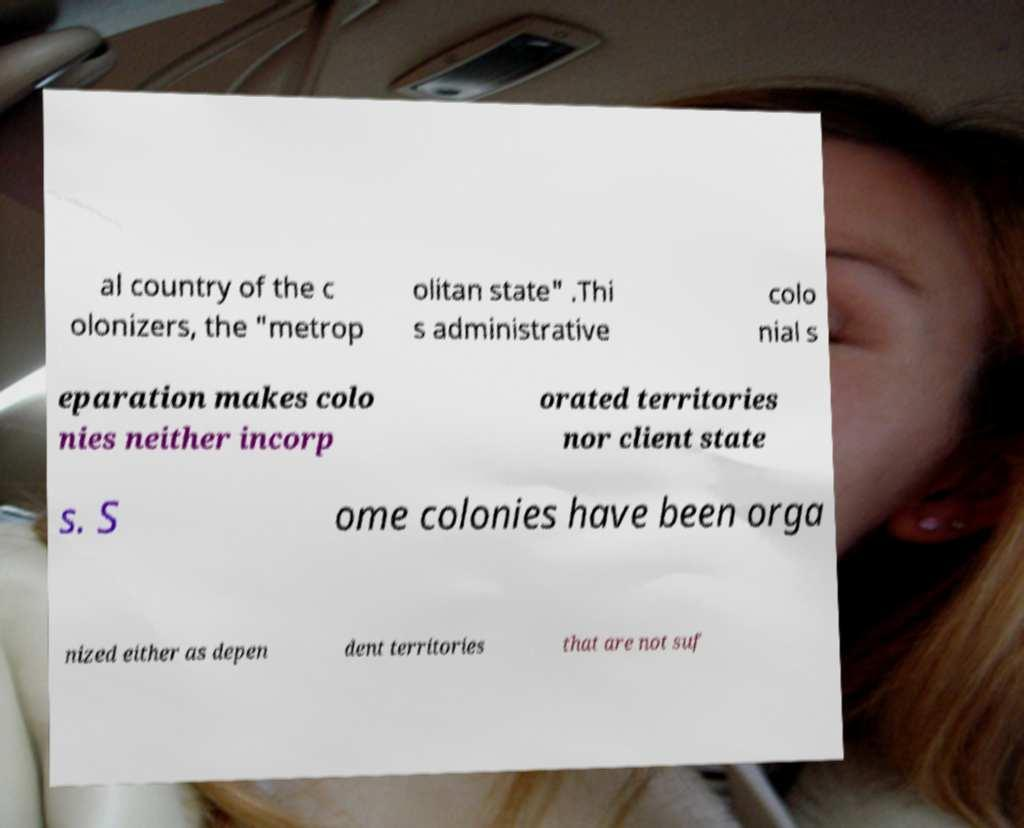Can you read and provide the text displayed in the image?This photo seems to have some interesting text. Can you extract and type it out for me? al country of the c olonizers, the "metrop olitan state" .Thi s administrative colo nial s eparation makes colo nies neither incorp orated territories nor client state s. S ome colonies have been orga nized either as depen dent territories that are not suf 